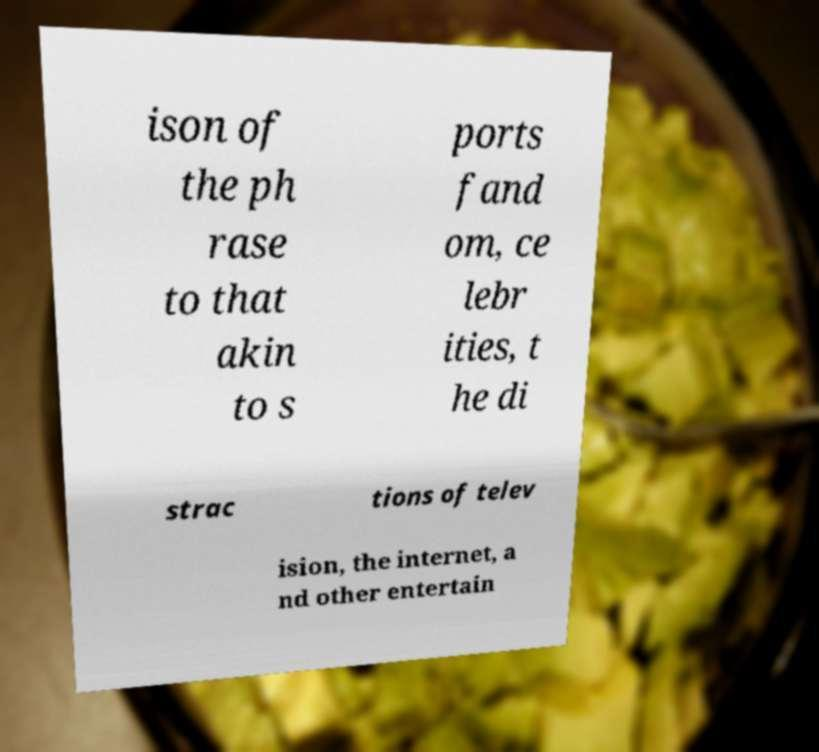There's text embedded in this image that I need extracted. Can you transcribe it verbatim? ison of the ph rase to that akin to s ports fand om, ce lebr ities, t he di strac tions of telev ision, the internet, a nd other entertain 